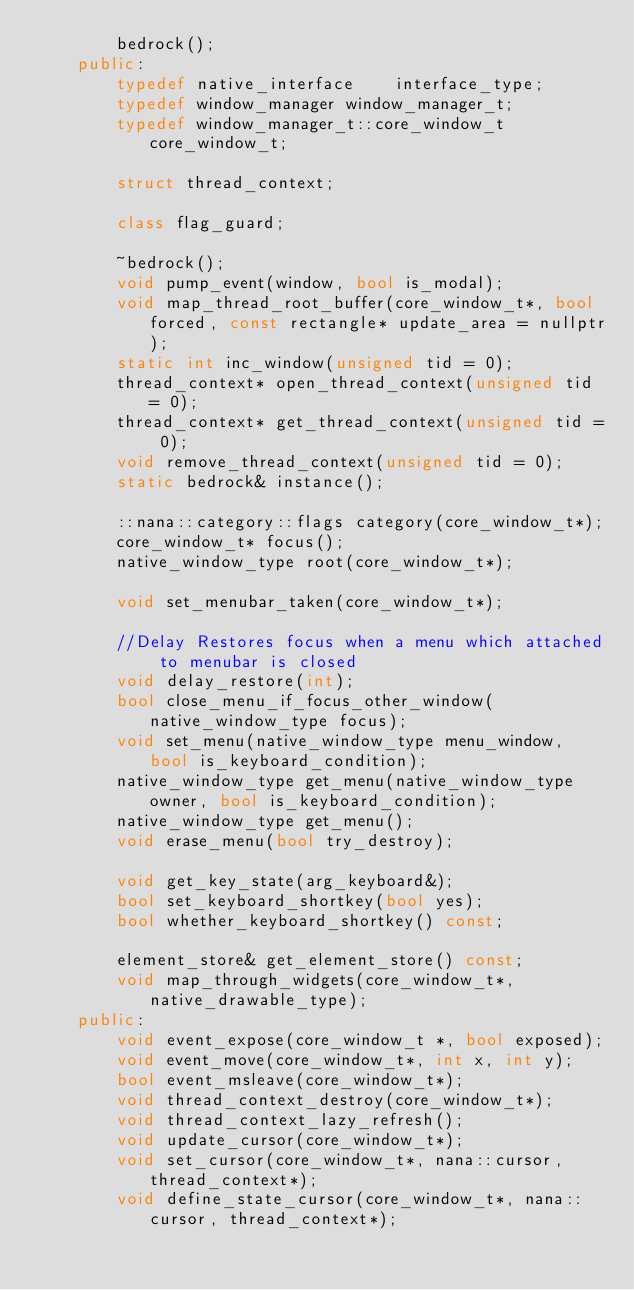<code> <loc_0><loc_0><loc_500><loc_500><_C++_>		bedrock();
	public:
		typedef native_interface	interface_type;
		typedef window_manager window_manager_t;
		typedef window_manager_t::core_window_t core_window_t;

		struct thread_context;

		class flag_guard;

		~bedrock();
		void pump_event(window, bool is_modal);
		void map_thread_root_buffer(core_window_t*, bool forced, const rectangle* update_area = nullptr);
		static int inc_window(unsigned tid = 0);
		thread_context* open_thread_context(unsigned tid = 0);
		thread_context* get_thread_context(unsigned tid = 0);
		void remove_thread_context(unsigned tid = 0);
		static bedrock& instance();

		::nana::category::flags category(core_window_t*);
		core_window_t* focus();
		native_window_type root(core_window_t*);

		void set_menubar_taken(core_window_t*);

		//Delay Restores focus when a menu which attached to menubar is closed
		void delay_restore(int);
		bool close_menu_if_focus_other_window(native_window_type focus);
		void set_menu(native_window_type menu_window, bool is_keyboard_condition);
		native_window_type get_menu(native_window_type owner, bool is_keyboard_condition);
		native_window_type get_menu();
		void erase_menu(bool try_destroy);

		void get_key_state(arg_keyboard&);
		bool set_keyboard_shortkey(bool yes);
		bool whether_keyboard_shortkey() const;

		element_store& get_element_store() const;
		void map_through_widgets(core_window_t*, native_drawable_type);
	public:
		void event_expose(core_window_t *, bool exposed);
		void event_move(core_window_t*, int x, int y);
		bool event_msleave(core_window_t*);
		void thread_context_destroy(core_window_t*);
		void thread_context_lazy_refresh();
		void update_cursor(core_window_t*);
		void set_cursor(core_window_t*, nana::cursor, thread_context*);
		void define_state_cursor(core_window_t*, nana::cursor, thread_context*);</code> 